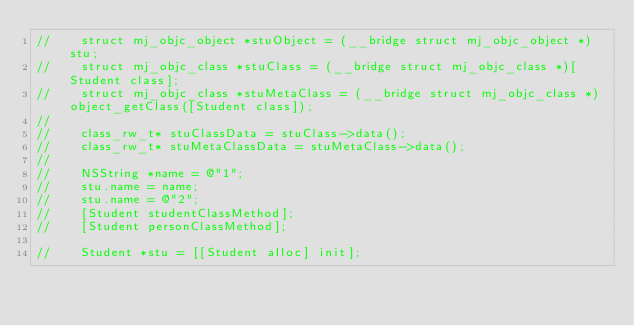<code> <loc_0><loc_0><loc_500><loc_500><_ObjectiveC_>//    struct mj_objc_object *stuObject = (__bridge struct mj_objc_object *)stu;
//    struct mj_objc_class *stuClass = (__bridge struct mj_objc_class *)[Student class];
//    struct mj_objc_class *stuMetaClass = (__bridge struct mj_objc_class *)object_getClass([Student class]);
//
//    class_rw_t* stuClassData = stuClass->data();
//    class_rw_t* stuMetaClassData = stuMetaClass->data();
//
//    NSString *name = @"1";
//    stu.name = name;
//    stu.name = @"2";
//    [Student studentClassMethod];
//    [Student personClassMethod];
    
//    Student *stu = [[Student alloc] init];</code> 